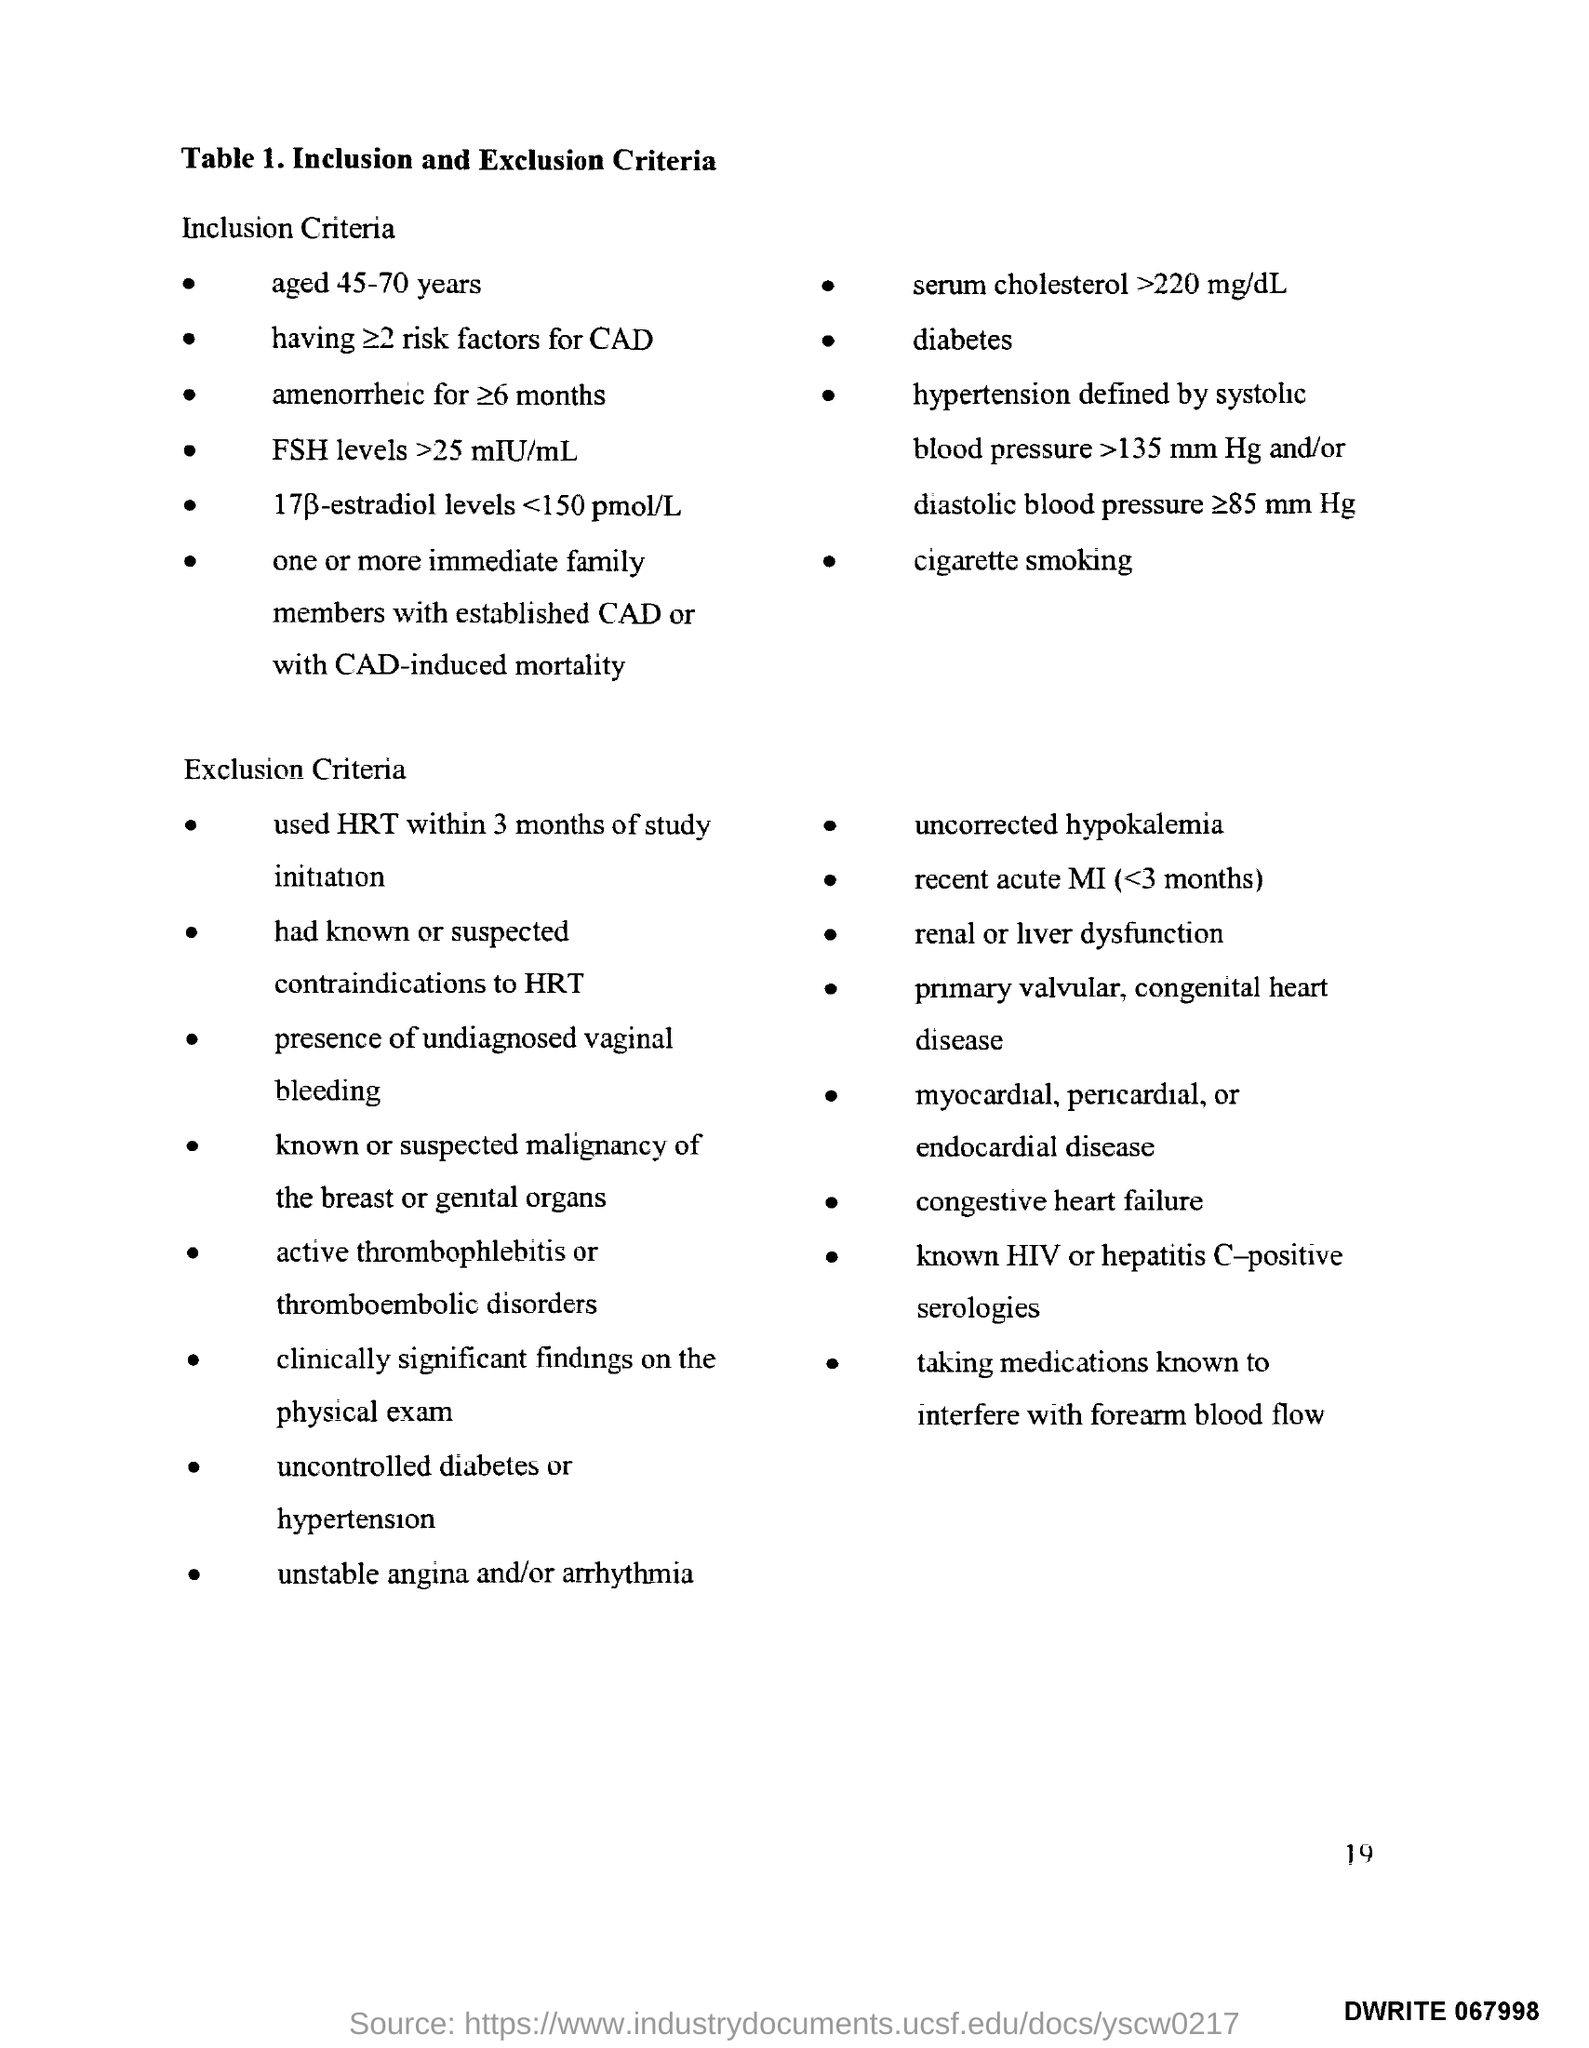Outline some significant characteristics in this image. The page number is 19, as declared. 